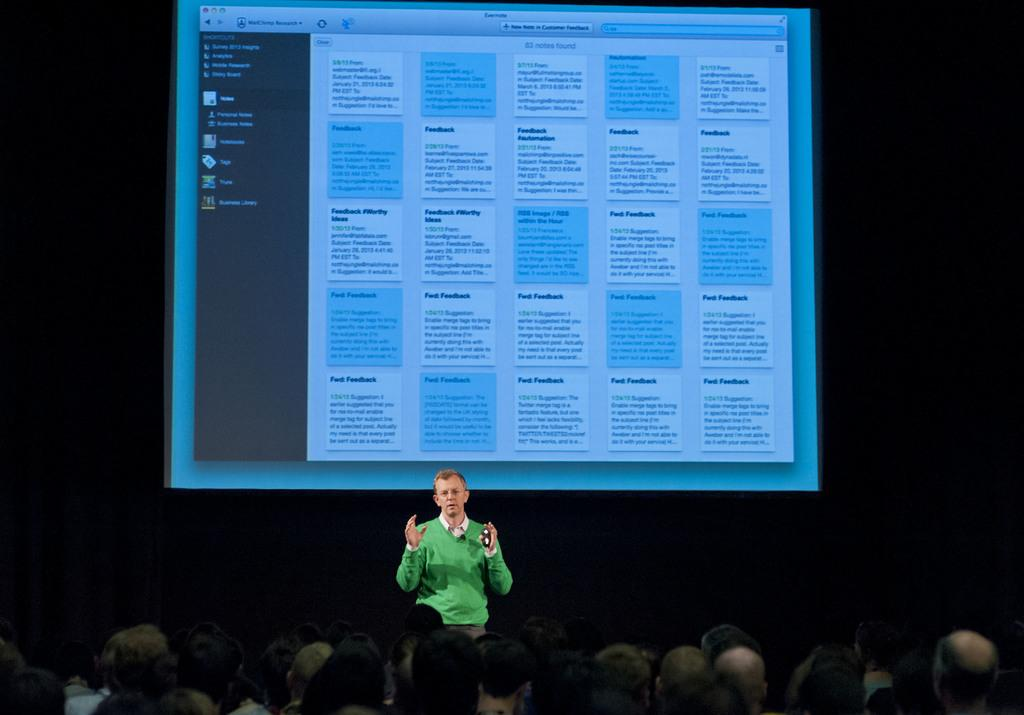What is the main subject of the image? There is a person standing on a dais in the image. Where are the other people in the image located? There are people at the bottom of the image. What can be seen in the background of the image? There is a screen in the background of the image. What verse is being recited by the person standing on the dais in the image? There is no indication in the image that the person is reciting a verse, so it cannot be determined from the picture. 